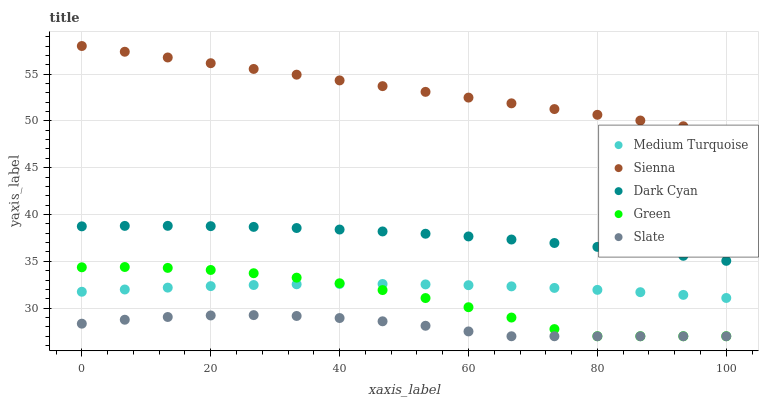Does Slate have the minimum area under the curve?
Answer yes or no. Yes. Does Sienna have the maximum area under the curve?
Answer yes or no. Yes. Does Dark Cyan have the minimum area under the curve?
Answer yes or no. No. Does Dark Cyan have the maximum area under the curve?
Answer yes or no. No. Is Sienna the smoothest?
Answer yes or no. Yes. Is Green the roughest?
Answer yes or no. Yes. Is Dark Cyan the smoothest?
Answer yes or no. No. Is Dark Cyan the roughest?
Answer yes or no. No. Does Slate have the lowest value?
Answer yes or no. Yes. Does Dark Cyan have the lowest value?
Answer yes or no. No. Does Sienna have the highest value?
Answer yes or no. Yes. Does Dark Cyan have the highest value?
Answer yes or no. No. Is Medium Turquoise less than Sienna?
Answer yes or no. Yes. Is Sienna greater than Medium Turquoise?
Answer yes or no. Yes. Does Slate intersect Green?
Answer yes or no. Yes. Is Slate less than Green?
Answer yes or no. No. Is Slate greater than Green?
Answer yes or no. No. Does Medium Turquoise intersect Sienna?
Answer yes or no. No. 